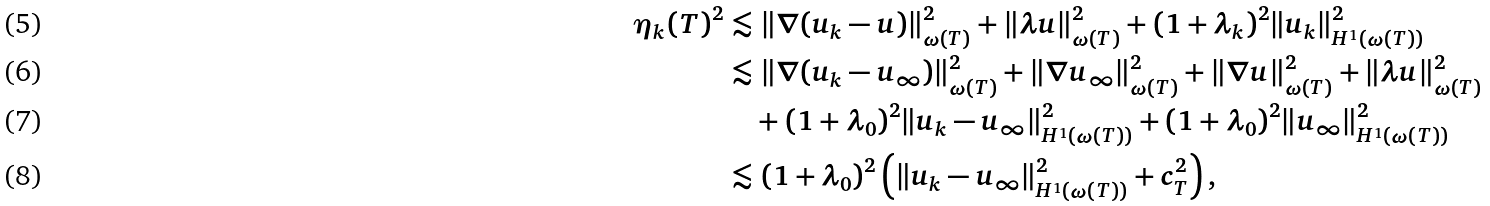<formula> <loc_0><loc_0><loc_500><loc_500>\eta _ { k } ( T ) ^ { 2 } & \lesssim \| \nabla ( u _ { k } - u ) \| _ { \omega ( T ) } ^ { 2 } + \| \lambda u \| _ { \omega ( T ) } ^ { 2 } + ( 1 + \lambda _ { k } ) ^ { 2 } \| u _ { k } \| _ { H ^ { 1 } ( \omega ( T ) ) } ^ { 2 } \\ & \lesssim \| \nabla ( u _ { k } - u _ { \infty } ) \| _ { \omega ( T ) } ^ { 2 } + \| \nabla u _ { \infty } \| _ { \omega ( T ) } ^ { 2 } + \| \nabla u \| _ { \omega ( T ) } ^ { 2 } + \| \lambda u \| _ { \omega ( T ) } ^ { 2 } \\ & \quad + ( 1 + \lambda _ { 0 } ) ^ { 2 } \| u _ { k } - u _ { \infty } \| _ { H ^ { 1 } ( \omega ( T ) ) } ^ { 2 } + ( 1 + \lambda _ { 0 } ) ^ { 2 } \| u _ { \infty } \| _ { H ^ { 1 } ( \omega ( T ) ) } ^ { 2 } \\ & \lesssim ( 1 + \lambda _ { 0 } ) ^ { 2 } \left ( \| u _ { k } - u _ { \infty } \| _ { H ^ { 1 } ( \omega ( T ) ) } ^ { 2 } + c _ { T } ^ { 2 } \right ) ,</formula> 